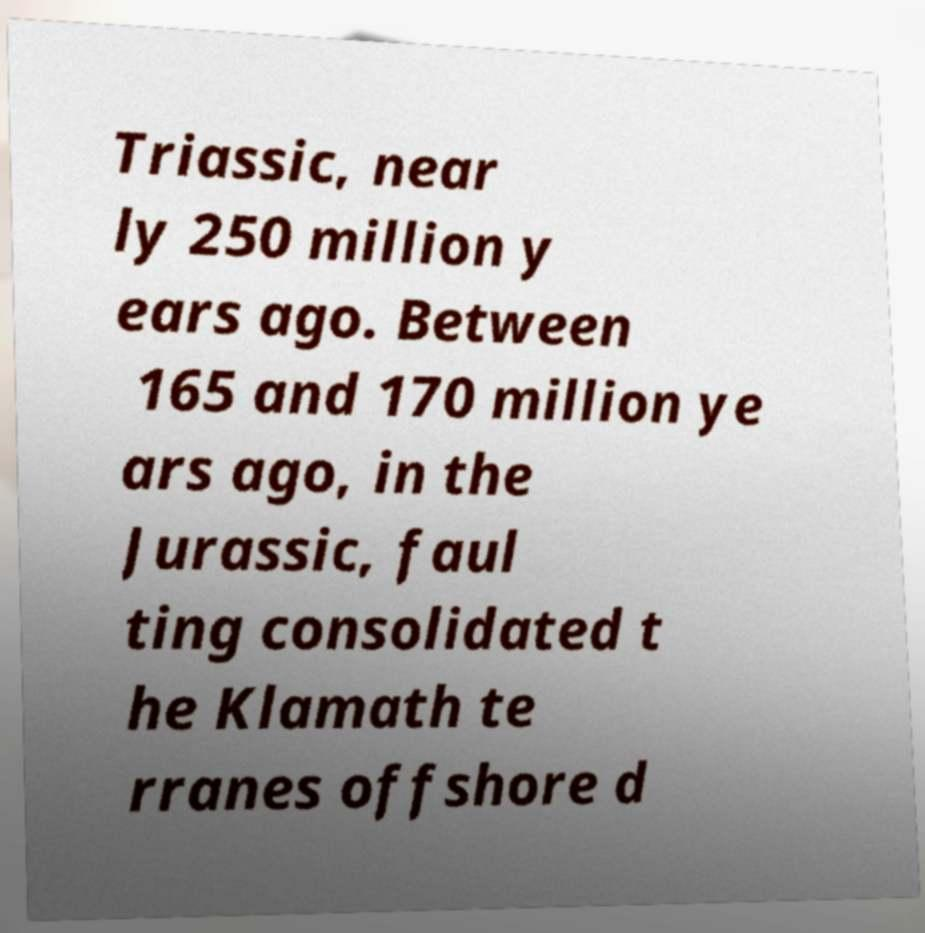There's text embedded in this image that I need extracted. Can you transcribe it verbatim? Triassic, near ly 250 million y ears ago. Between 165 and 170 million ye ars ago, in the Jurassic, faul ting consolidated t he Klamath te rranes offshore d 